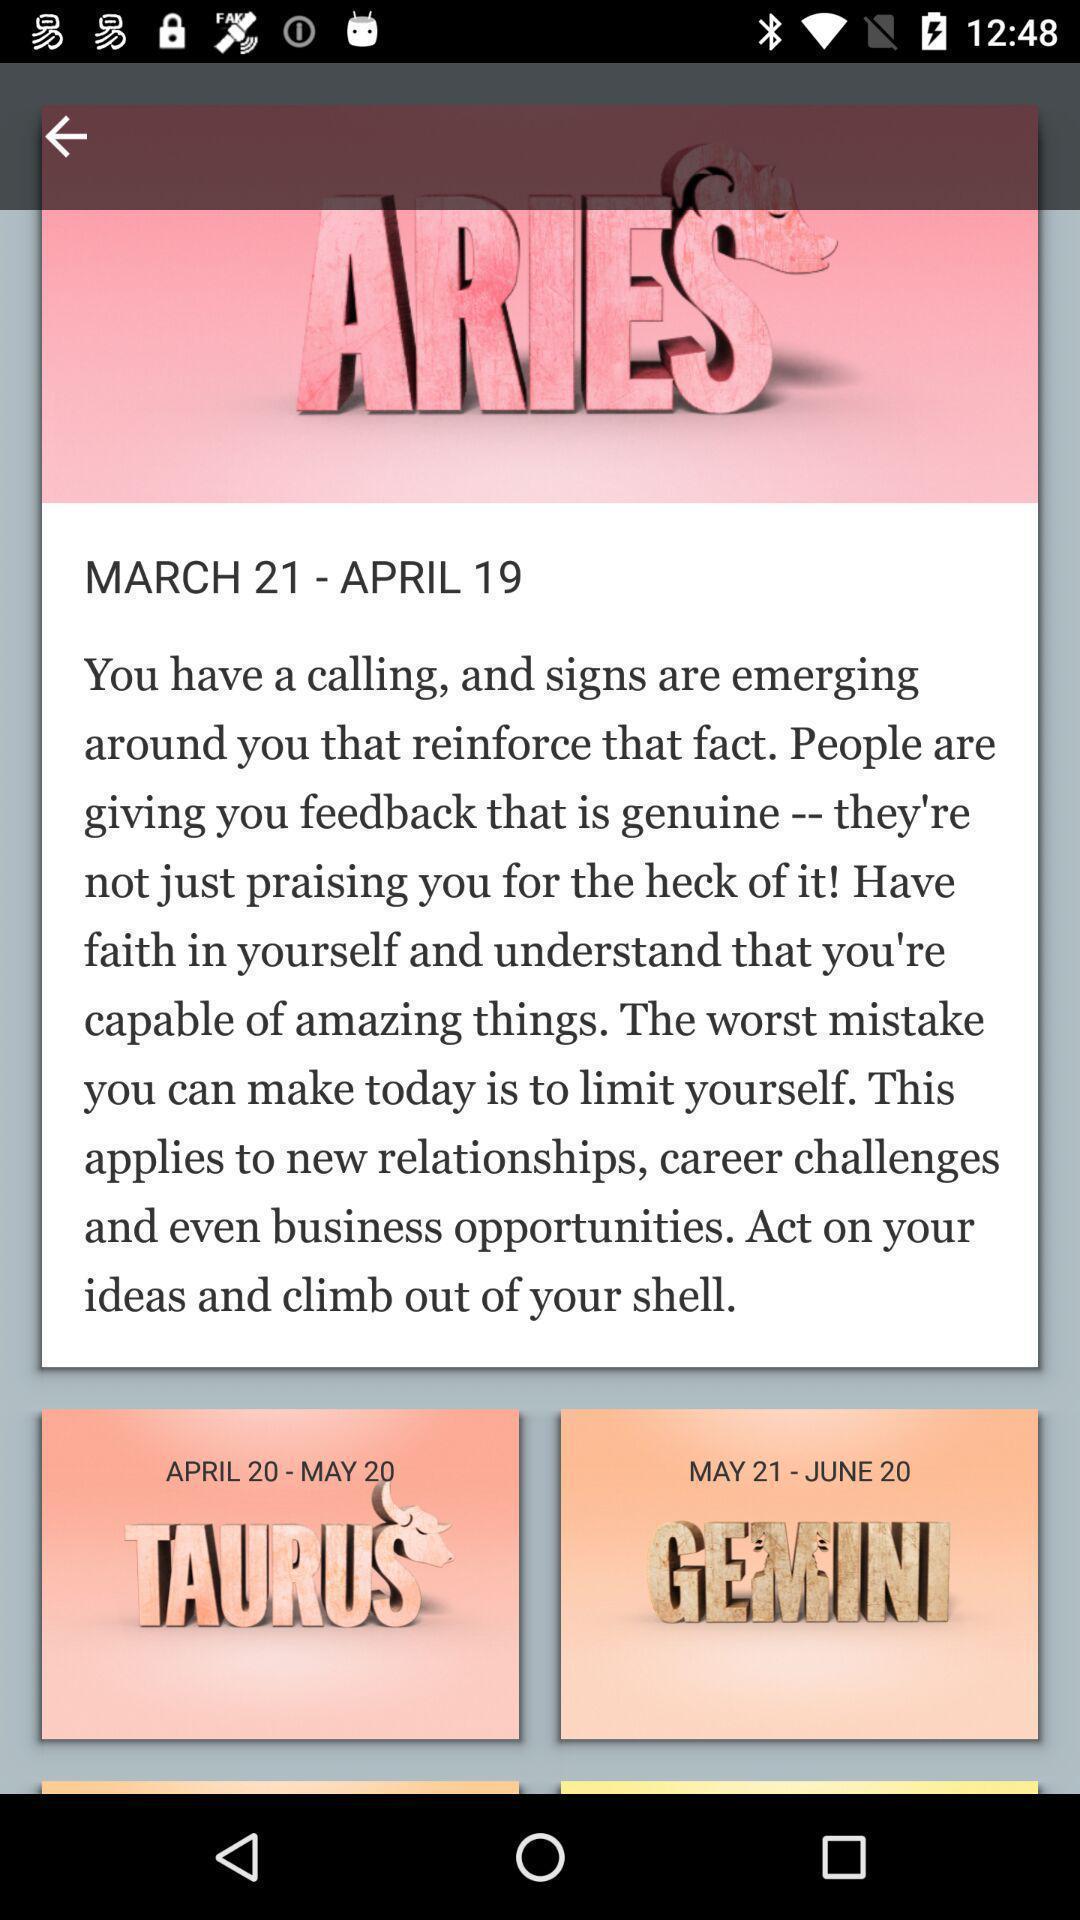Describe this image in words. Screen shows updates on signs on a device. 